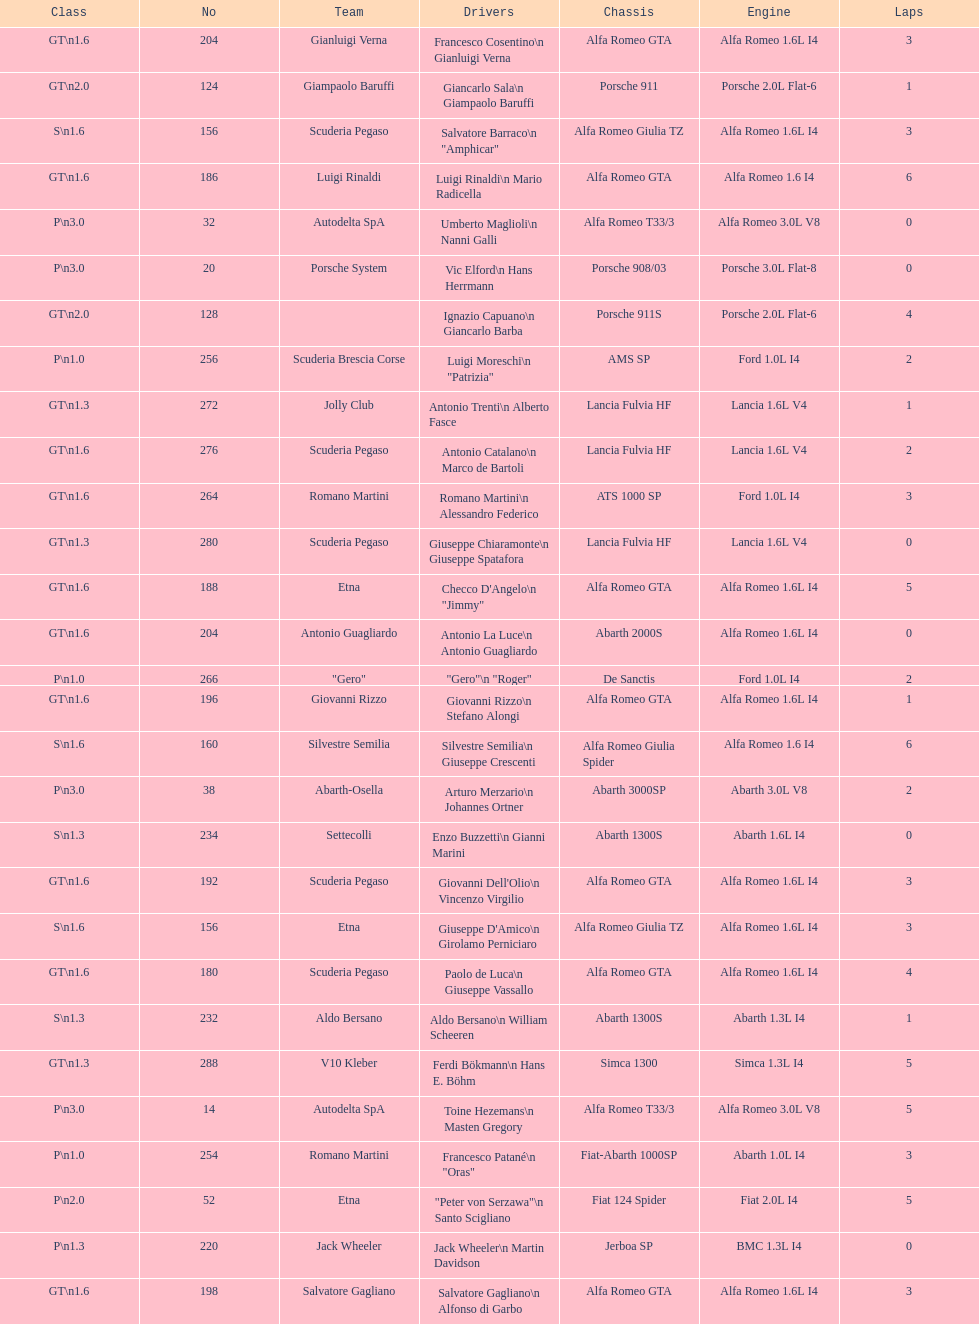How many teams failed to finish the race after 2 laps? 4. 